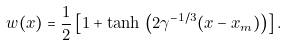<formula> <loc_0><loc_0><loc_500><loc_500>w ( x ) = \frac { 1 } { 2 } \left [ 1 + \tanh \, \left ( 2 \gamma ^ { - 1 / 3 } ( x - x _ { m } ) \right ) \right ] .</formula> 